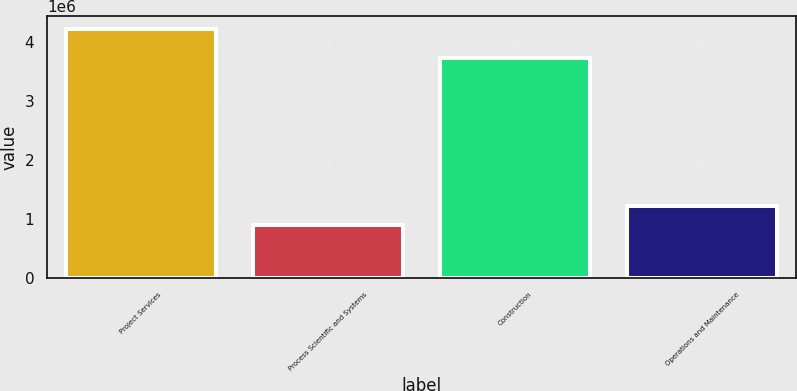<chart> <loc_0><loc_0><loc_500><loc_500><bar_chart><fcel>Project Services<fcel>Process Scientific and Systems<fcel>Construction<fcel>Operations and Maintenance<nl><fcel>4.2249e+06<fcel>888405<fcel>3.7221e+06<fcel>1.22205e+06<nl></chart> 